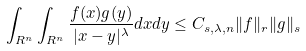<formula> <loc_0><loc_0><loc_500><loc_500>\int _ { R ^ { n } } \int _ { R ^ { n } } \frac { f ( x ) g ( y ) } { | x - y | ^ { \lambda } } d x d y \leq C _ { s , \lambda , n } \| f \| _ { r } \| g \| _ { s }</formula> 